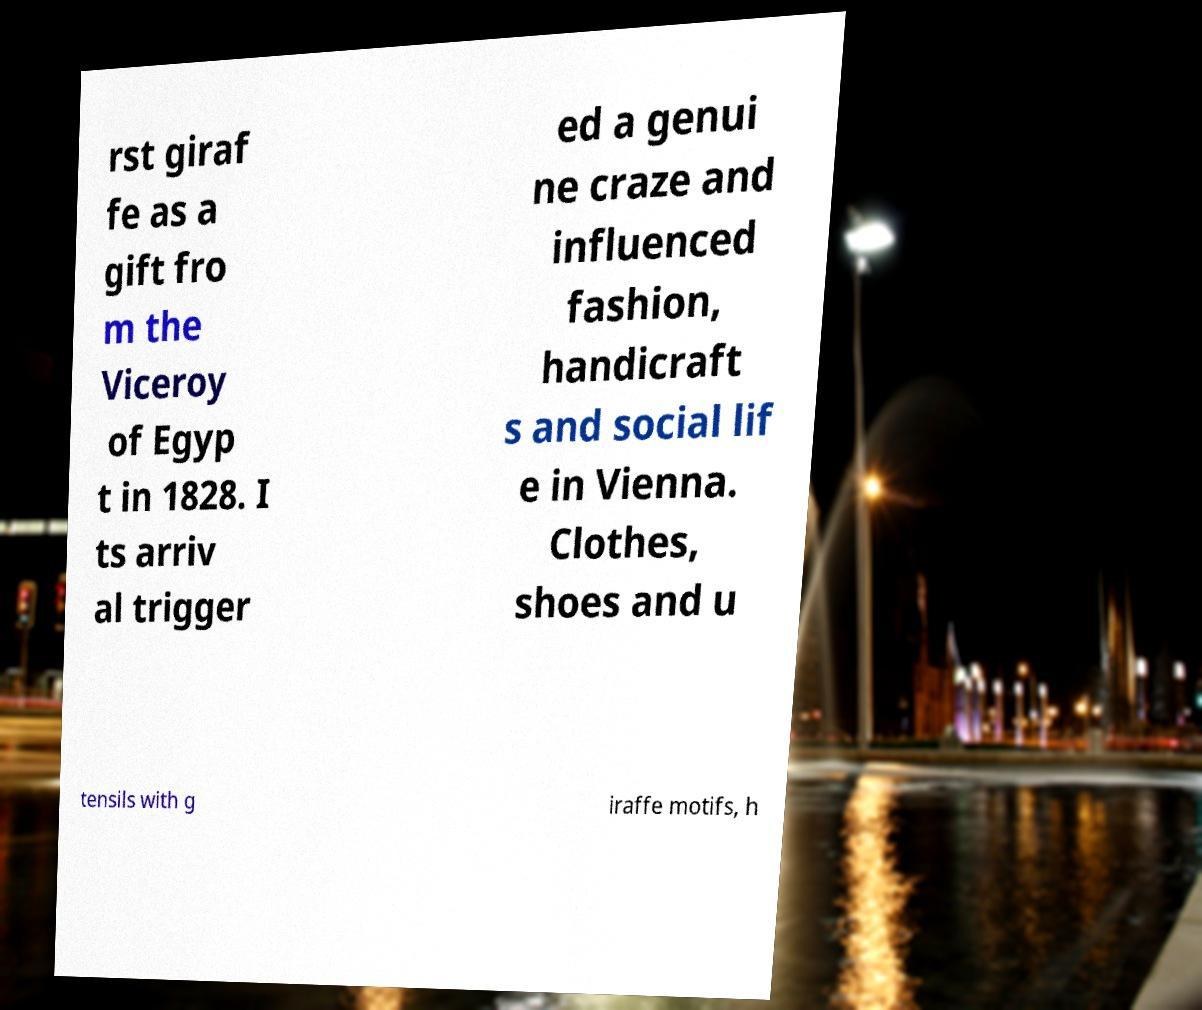Can you read and provide the text displayed in the image?This photo seems to have some interesting text. Can you extract and type it out for me? rst giraf fe as a gift fro m the Viceroy of Egyp t in 1828. I ts arriv al trigger ed a genui ne craze and influenced fashion, handicraft s and social lif e in Vienna. Clothes, shoes and u tensils with g iraffe motifs, h 